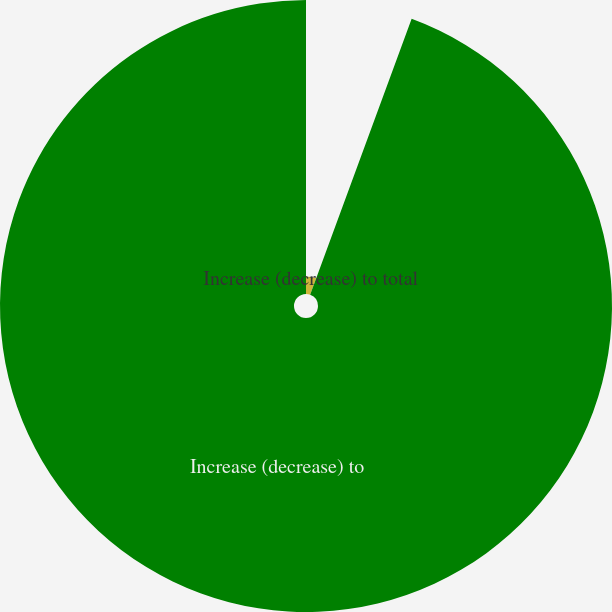<chart> <loc_0><loc_0><loc_500><loc_500><pie_chart><fcel>Increase (decrease) to total<fcel>Increase (decrease) to<nl><fcel>5.61%<fcel>94.39%<nl></chart> 